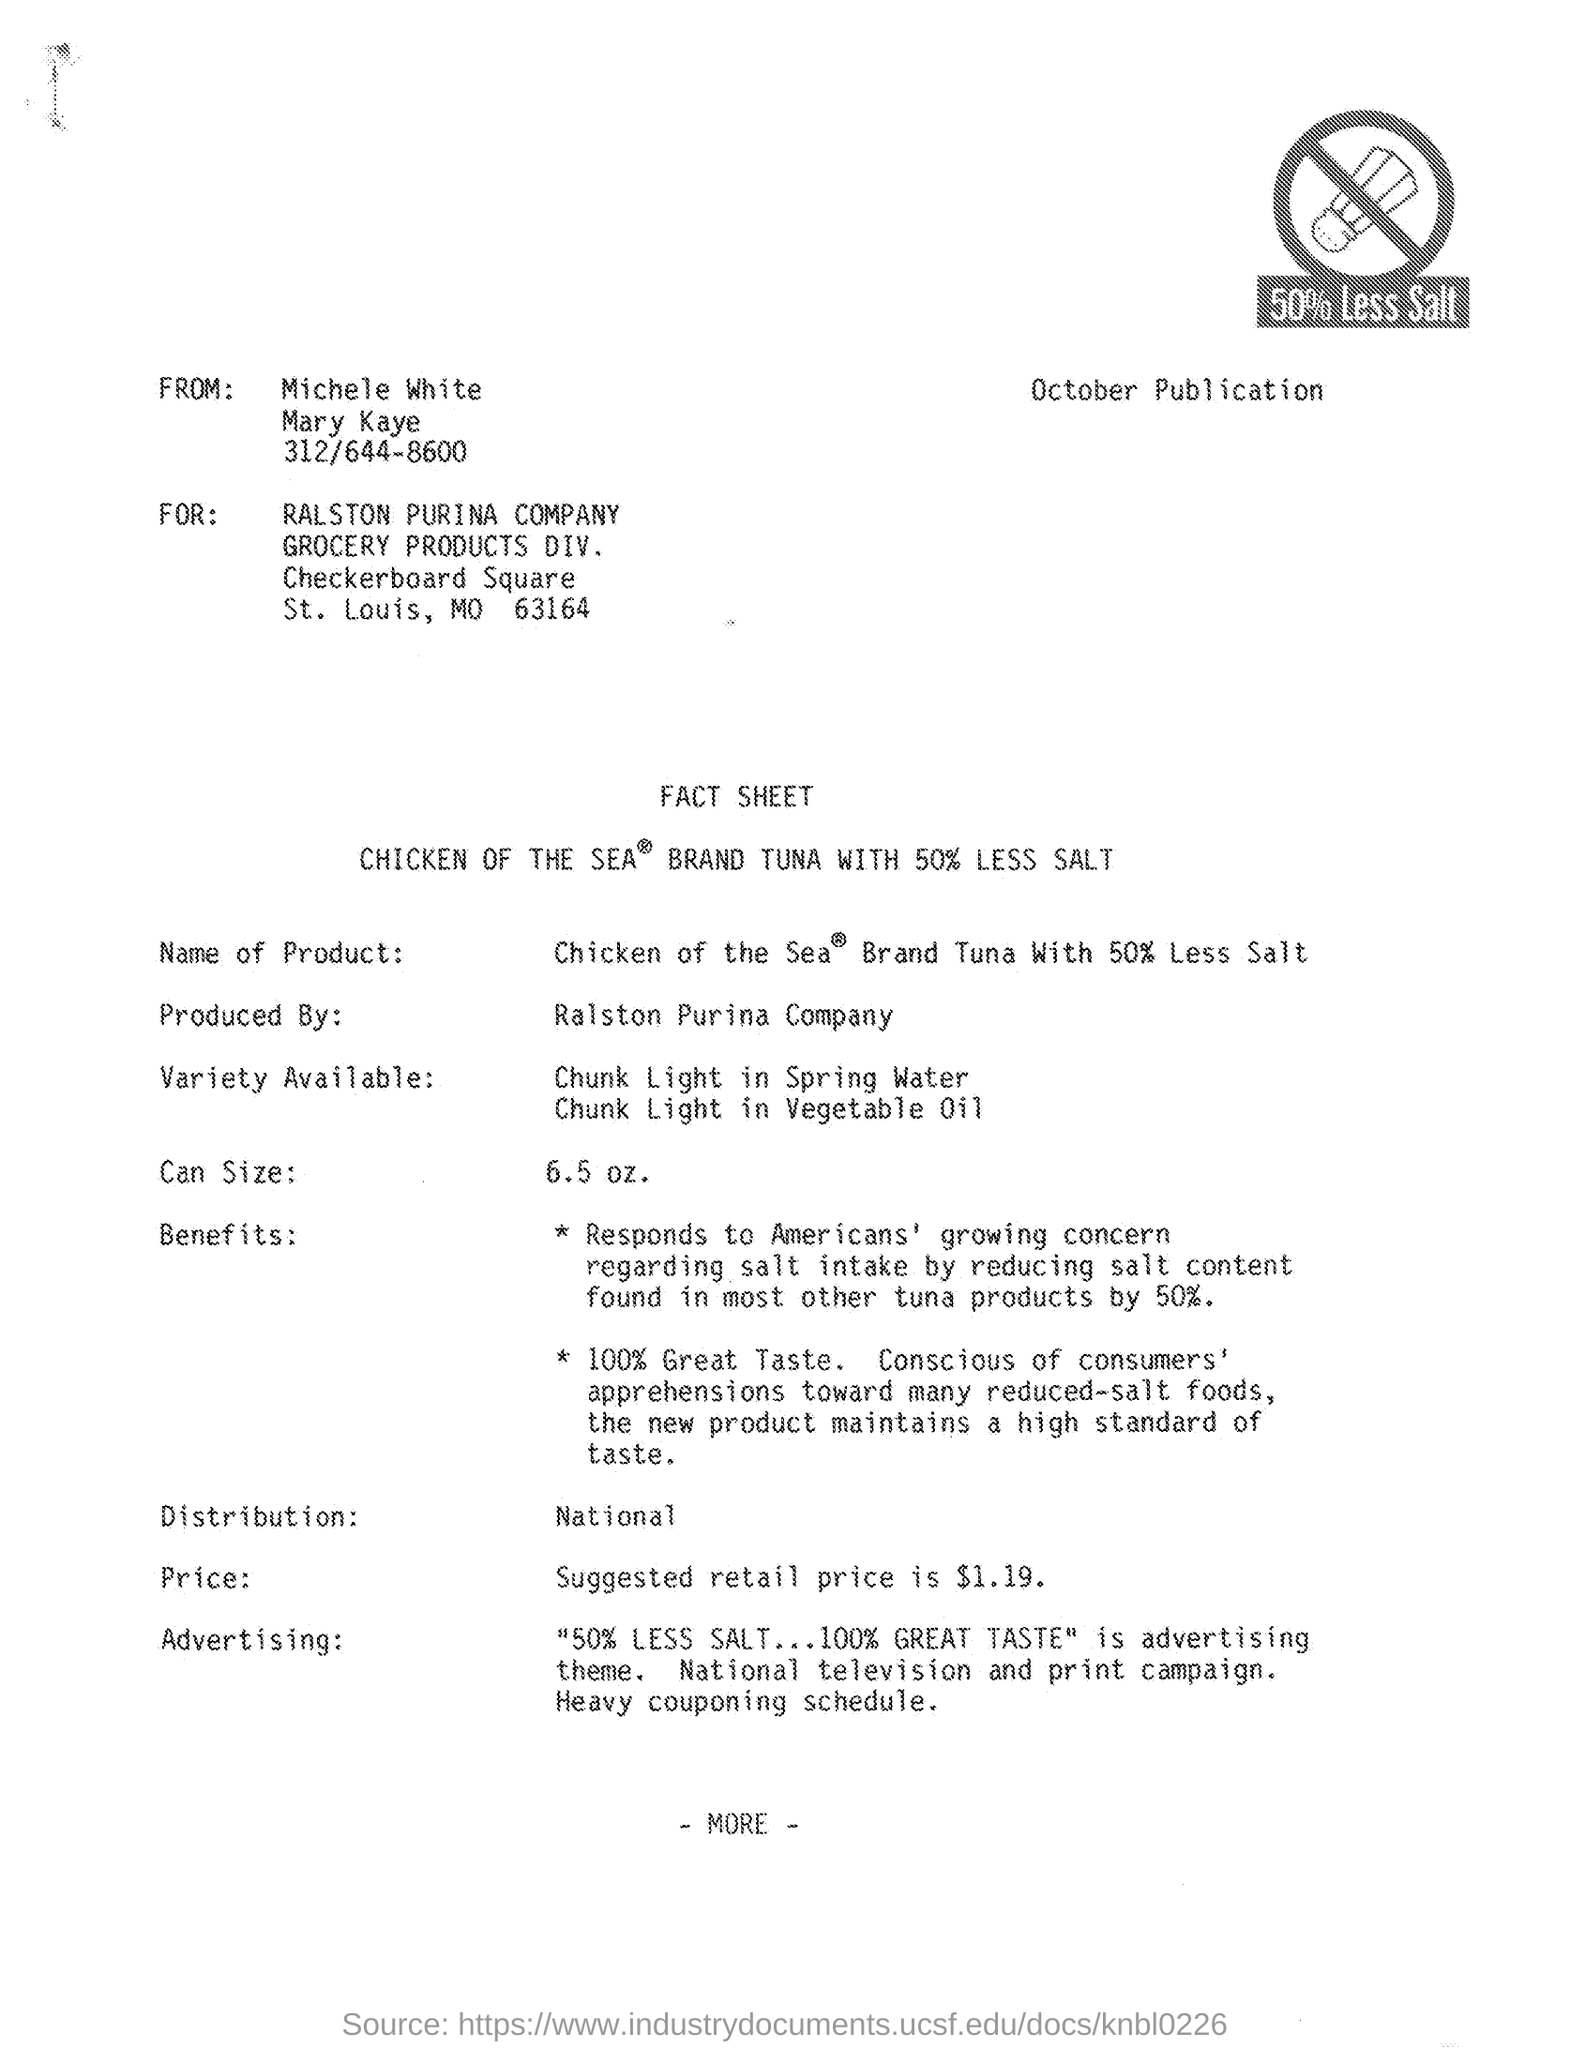Give some essential details in this illustration. The suggested retail price mentioned in the given fact sheet is $1.19. The specified div is "Grocery products DIV. The sheet was delivered by Michele White. The reference "for which company it was published ? Ralston Purina Company.." is a question asking for information about the company that published a particular piece of information. The fact sheet states that the can size is 6.5 ounces. 